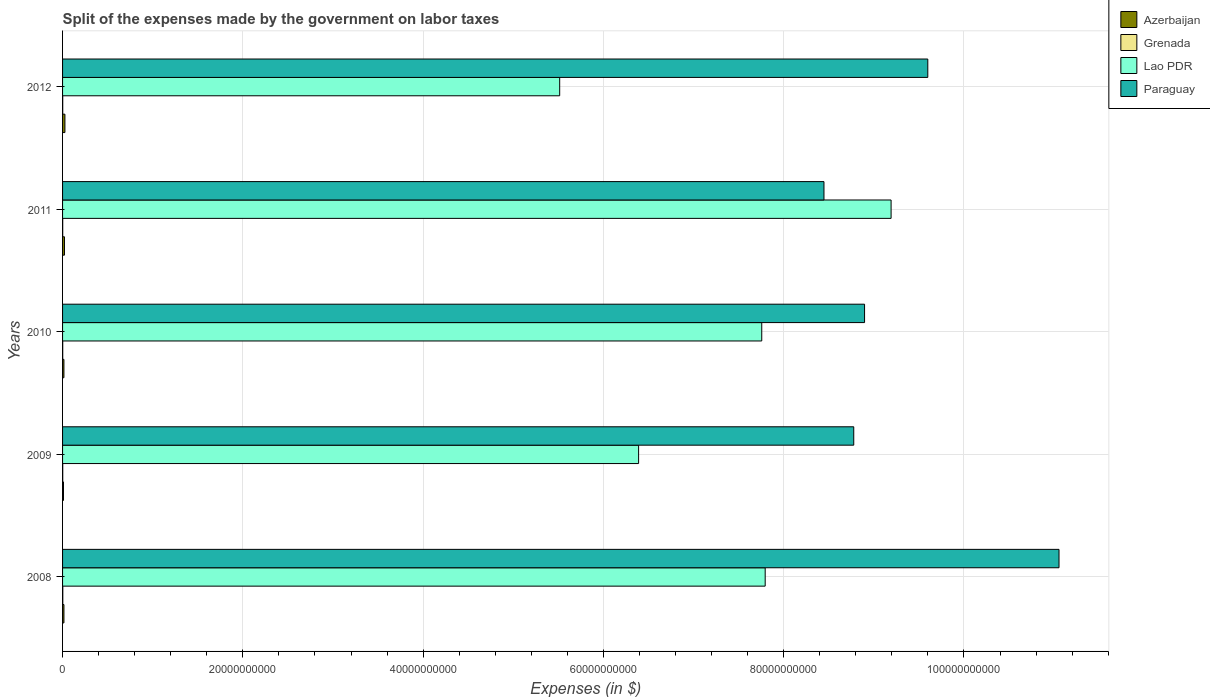How many different coloured bars are there?
Your response must be concise. 4. Are the number of bars per tick equal to the number of legend labels?
Keep it short and to the point. Yes. In how many cases, is the number of bars for a given year not equal to the number of legend labels?
Your answer should be compact. 0. What is the expenses made by the government on labor taxes in Grenada in 2012?
Your answer should be very brief. 1.64e+07. Across all years, what is the maximum expenses made by the government on labor taxes in Azerbaijan?
Your answer should be compact. 2.61e+08. Across all years, what is the minimum expenses made by the government on labor taxes in Paraguay?
Provide a short and direct response. 8.45e+1. What is the total expenses made by the government on labor taxes in Lao PDR in the graph?
Keep it short and to the point. 3.66e+11. What is the difference between the expenses made by the government on labor taxes in Grenada in 2009 and that in 2010?
Make the answer very short. 1.40e+06. What is the difference between the expenses made by the government on labor taxes in Grenada in 2009 and the expenses made by the government on labor taxes in Lao PDR in 2012?
Your answer should be very brief. -5.51e+1. What is the average expenses made by the government on labor taxes in Azerbaijan per year?
Offer a very short reply. 1.75e+08. In the year 2010, what is the difference between the expenses made by the government on labor taxes in Lao PDR and expenses made by the government on labor taxes in Grenada?
Offer a very short reply. 7.76e+1. In how many years, is the expenses made by the government on labor taxes in Lao PDR greater than 36000000000 $?
Your answer should be compact. 5. What is the ratio of the expenses made by the government on labor taxes in Azerbaijan in 2009 to that in 2011?
Make the answer very short. 0.48. Is the expenses made by the government on labor taxes in Grenada in 2009 less than that in 2012?
Ensure brevity in your answer.  No. Is the difference between the expenses made by the government on labor taxes in Lao PDR in 2008 and 2011 greater than the difference between the expenses made by the government on labor taxes in Grenada in 2008 and 2011?
Your response must be concise. No. What is the difference between the highest and the second highest expenses made by the government on labor taxes in Grenada?
Offer a very short reply. 7.20e+06. What is the difference between the highest and the lowest expenses made by the government on labor taxes in Grenada?
Ensure brevity in your answer.  1.11e+07. Is it the case that in every year, the sum of the expenses made by the government on labor taxes in Paraguay and expenses made by the government on labor taxes in Grenada is greater than the sum of expenses made by the government on labor taxes in Azerbaijan and expenses made by the government on labor taxes in Lao PDR?
Keep it short and to the point. Yes. What does the 4th bar from the top in 2009 represents?
Your response must be concise. Azerbaijan. What does the 2nd bar from the bottom in 2012 represents?
Ensure brevity in your answer.  Grenada. Are all the bars in the graph horizontal?
Offer a very short reply. Yes. How many years are there in the graph?
Your answer should be very brief. 5. How many legend labels are there?
Your answer should be very brief. 4. How are the legend labels stacked?
Keep it short and to the point. Vertical. What is the title of the graph?
Keep it short and to the point. Split of the expenses made by the government on labor taxes. What is the label or title of the X-axis?
Keep it short and to the point. Expenses (in $). What is the label or title of the Y-axis?
Provide a succinct answer. Years. What is the Expenses (in $) in Azerbaijan in 2008?
Your answer should be compact. 1.52e+08. What is the Expenses (in $) of Grenada in 2008?
Your response must be concise. 2.60e+07. What is the Expenses (in $) of Lao PDR in 2008?
Offer a very short reply. 7.80e+1. What is the Expenses (in $) of Paraguay in 2008?
Provide a short and direct response. 1.11e+11. What is the Expenses (in $) in Azerbaijan in 2009?
Give a very brief answer. 1.02e+08. What is the Expenses (in $) of Grenada in 2009?
Keep it short and to the point. 1.88e+07. What is the Expenses (in $) of Lao PDR in 2009?
Your answer should be compact. 6.39e+1. What is the Expenses (in $) of Paraguay in 2009?
Offer a very short reply. 8.78e+1. What is the Expenses (in $) of Azerbaijan in 2010?
Your answer should be very brief. 1.51e+08. What is the Expenses (in $) of Grenada in 2010?
Provide a short and direct response. 1.74e+07. What is the Expenses (in $) of Lao PDR in 2010?
Your answer should be compact. 7.76e+1. What is the Expenses (in $) of Paraguay in 2010?
Provide a succinct answer. 8.90e+1. What is the Expenses (in $) of Azerbaijan in 2011?
Your answer should be compact. 2.11e+08. What is the Expenses (in $) of Grenada in 2011?
Your answer should be compact. 1.49e+07. What is the Expenses (in $) in Lao PDR in 2011?
Keep it short and to the point. 9.19e+1. What is the Expenses (in $) in Paraguay in 2011?
Offer a terse response. 8.45e+1. What is the Expenses (in $) of Azerbaijan in 2012?
Offer a terse response. 2.61e+08. What is the Expenses (in $) in Grenada in 2012?
Give a very brief answer. 1.64e+07. What is the Expenses (in $) in Lao PDR in 2012?
Ensure brevity in your answer.  5.52e+1. What is the Expenses (in $) of Paraguay in 2012?
Ensure brevity in your answer.  9.60e+1. Across all years, what is the maximum Expenses (in $) of Azerbaijan?
Keep it short and to the point. 2.61e+08. Across all years, what is the maximum Expenses (in $) of Grenada?
Your response must be concise. 2.60e+07. Across all years, what is the maximum Expenses (in $) of Lao PDR?
Make the answer very short. 9.19e+1. Across all years, what is the maximum Expenses (in $) in Paraguay?
Your response must be concise. 1.11e+11. Across all years, what is the minimum Expenses (in $) in Azerbaijan?
Your answer should be very brief. 1.02e+08. Across all years, what is the minimum Expenses (in $) of Grenada?
Offer a very short reply. 1.49e+07. Across all years, what is the minimum Expenses (in $) of Lao PDR?
Your answer should be compact. 5.52e+1. Across all years, what is the minimum Expenses (in $) in Paraguay?
Your answer should be very brief. 8.45e+1. What is the total Expenses (in $) in Azerbaijan in the graph?
Your response must be concise. 8.77e+08. What is the total Expenses (in $) in Grenada in the graph?
Provide a short and direct response. 9.35e+07. What is the total Expenses (in $) in Lao PDR in the graph?
Your answer should be compact. 3.66e+11. What is the total Expenses (in $) in Paraguay in the graph?
Provide a short and direct response. 4.68e+11. What is the difference between the Expenses (in $) of Azerbaijan in 2008 and that in 2009?
Your answer should be compact. 5.05e+07. What is the difference between the Expenses (in $) of Grenada in 2008 and that in 2009?
Offer a very short reply. 7.20e+06. What is the difference between the Expenses (in $) in Lao PDR in 2008 and that in 2009?
Your answer should be compact. 1.40e+1. What is the difference between the Expenses (in $) of Paraguay in 2008 and that in 2009?
Make the answer very short. 2.28e+1. What is the difference between the Expenses (in $) of Azerbaijan in 2008 and that in 2010?
Provide a short and direct response. 1.30e+06. What is the difference between the Expenses (in $) of Grenada in 2008 and that in 2010?
Ensure brevity in your answer.  8.60e+06. What is the difference between the Expenses (in $) in Lao PDR in 2008 and that in 2010?
Your response must be concise. 3.81e+08. What is the difference between the Expenses (in $) in Paraguay in 2008 and that in 2010?
Offer a very short reply. 2.16e+1. What is the difference between the Expenses (in $) in Azerbaijan in 2008 and that in 2011?
Provide a succinct answer. -5.88e+07. What is the difference between the Expenses (in $) in Grenada in 2008 and that in 2011?
Make the answer very short. 1.11e+07. What is the difference between the Expenses (in $) of Lao PDR in 2008 and that in 2011?
Your response must be concise. -1.40e+1. What is the difference between the Expenses (in $) in Paraguay in 2008 and that in 2011?
Give a very brief answer. 2.61e+1. What is the difference between the Expenses (in $) in Azerbaijan in 2008 and that in 2012?
Your response must be concise. -1.09e+08. What is the difference between the Expenses (in $) in Grenada in 2008 and that in 2012?
Offer a very short reply. 9.60e+06. What is the difference between the Expenses (in $) of Lao PDR in 2008 and that in 2012?
Provide a short and direct response. 2.28e+1. What is the difference between the Expenses (in $) of Paraguay in 2008 and that in 2012?
Your answer should be very brief. 1.46e+1. What is the difference between the Expenses (in $) in Azerbaijan in 2009 and that in 2010?
Offer a very short reply. -4.92e+07. What is the difference between the Expenses (in $) of Grenada in 2009 and that in 2010?
Make the answer very short. 1.40e+06. What is the difference between the Expenses (in $) in Lao PDR in 2009 and that in 2010?
Keep it short and to the point. -1.37e+1. What is the difference between the Expenses (in $) in Paraguay in 2009 and that in 2010?
Your answer should be compact. -1.20e+09. What is the difference between the Expenses (in $) in Azerbaijan in 2009 and that in 2011?
Offer a very short reply. -1.09e+08. What is the difference between the Expenses (in $) of Grenada in 2009 and that in 2011?
Provide a succinct answer. 3.90e+06. What is the difference between the Expenses (in $) in Lao PDR in 2009 and that in 2011?
Provide a succinct answer. -2.80e+1. What is the difference between the Expenses (in $) of Paraguay in 2009 and that in 2011?
Make the answer very short. 3.30e+09. What is the difference between the Expenses (in $) of Azerbaijan in 2009 and that in 2012?
Provide a short and direct response. -1.60e+08. What is the difference between the Expenses (in $) of Grenada in 2009 and that in 2012?
Give a very brief answer. 2.40e+06. What is the difference between the Expenses (in $) of Lao PDR in 2009 and that in 2012?
Ensure brevity in your answer.  8.76e+09. What is the difference between the Expenses (in $) in Paraguay in 2009 and that in 2012?
Your answer should be compact. -8.21e+09. What is the difference between the Expenses (in $) of Azerbaijan in 2010 and that in 2011?
Ensure brevity in your answer.  -6.01e+07. What is the difference between the Expenses (in $) of Grenada in 2010 and that in 2011?
Your response must be concise. 2.50e+06. What is the difference between the Expenses (in $) of Lao PDR in 2010 and that in 2011?
Your response must be concise. -1.43e+1. What is the difference between the Expenses (in $) in Paraguay in 2010 and that in 2011?
Keep it short and to the point. 4.50e+09. What is the difference between the Expenses (in $) of Azerbaijan in 2010 and that in 2012?
Your response must be concise. -1.10e+08. What is the difference between the Expenses (in $) in Lao PDR in 2010 and that in 2012?
Your answer should be compact. 2.24e+1. What is the difference between the Expenses (in $) in Paraguay in 2010 and that in 2012?
Offer a terse response. -7.01e+09. What is the difference between the Expenses (in $) in Azerbaijan in 2011 and that in 2012?
Make the answer very short. -5.04e+07. What is the difference between the Expenses (in $) in Grenada in 2011 and that in 2012?
Provide a short and direct response. -1.50e+06. What is the difference between the Expenses (in $) of Lao PDR in 2011 and that in 2012?
Ensure brevity in your answer.  3.68e+1. What is the difference between the Expenses (in $) of Paraguay in 2011 and that in 2012?
Keep it short and to the point. -1.15e+1. What is the difference between the Expenses (in $) in Azerbaijan in 2008 and the Expenses (in $) in Grenada in 2009?
Offer a terse response. 1.33e+08. What is the difference between the Expenses (in $) of Azerbaijan in 2008 and the Expenses (in $) of Lao PDR in 2009?
Offer a terse response. -6.38e+1. What is the difference between the Expenses (in $) of Azerbaijan in 2008 and the Expenses (in $) of Paraguay in 2009?
Give a very brief answer. -8.76e+1. What is the difference between the Expenses (in $) in Grenada in 2008 and the Expenses (in $) in Lao PDR in 2009?
Keep it short and to the point. -6.39e+1. What is the difference between the Expenses (in $) in Grenada in 2008 and the Expenses (in $) in Paraguay in 2009?
Offer a terse response. -8.77e+1. What is the difference between the Expenses (in $) in Lao PDR in 2008 and the Expenses (in $) in Paraguay in 2009?
Offer a very short reply. -9.82e+09. What is the difference between the Expenses (in $) of Azerbaijan in 2008 and the Expenses (in $) of Grenada in 2010?
Give a very brief answer. 1.35e+08. What is the difference between the Expenses (in $) of Azerbaijan in 2008 and the Expenses (in $) of Lao PDR in 2010?
Ensure brevity in your answer.  -7.74e+1. What is the difference between the Expenses (in $) of Azerbaijan in 2008 and the Expenses (in $) of Paraguay in 2010?
Your answer should be very brief. -8.88e+1. What is the difference between the Expenses (in $) of Grenada in 2008 and the Expenses (in $) of Lao PDR in 2010?
Ensure brevity in your answer.  -7.75e+1. What is the difference between the Expenses (in $) in Grenada in 2008 and the Expenses (in $) in Paraguay in 2010?
Offer a terse response. -8.89e+1. What is the difference between the Expenses (in $) of Lao PDR in 2008 and the Expenses (in $) of Paraguay in 2010?
Offer a terse response. -1.10e+1. What is the difference between the Expenses (in $) of Azerbaijan in 2008 and the Expenses (in $) of Grenada in 2011?
Give a very brief answer. 1.37e+08. What is the difference between the Expenses (in $) of Azerbaijan in 2008 and the Expenses (in $) of Lao PDR in 2011?
Your answer should be compact. -9.18e+1. What is the difference between the Expenses (in $) of Azerbaijan in 2008 and the Expenses (in $) of Paraguay in 2011?
Offer a terse response. -8.43e+1. What is the difference between the Expenses (in $) of Grenada in 2008 and the Expenses (in $) of Lao PDR in 2011?
Your answer should be compact. -9.19e+1. What is the difference between the Expenses (in $) in Grenada in 2008 and the Expenses (in $) in Paraguay in 2011?
Make the answer very short. -8.44e+1. What is the difference between the Expenses (in $) in Lao PDR in 2008 and the Expenses (in $) in Paraguay in 2011?
Keep it short and to the point. -6.52e+09. What is the difference between the Expenses (in $) of Azerbaijan in 2008 and the Expenses (in $) of Grenada in 2012?
Provide a succinct answer. 1.36e+08. What is the difference between the Expenses (in $) of Azerbaijan in 2008 and the Expenses (in $) of Lao PDR in 2012?
Provide a short and direct response. -5.50e+1. What is the difference between the Expenses (in $) of Azerbaijan in 2008 and the Expenses (in $) of Paraguay in 2012?
Offer a terse response. -9.58e+1. What is the difference between the Expenses (in $) in Grenada in 2008 and the Expenses (in $) in Lao PDR in 2012?
Provide a succinct answer. -5.51e+1. What is the difference between the Expenses (in $) in Grenada in 2008 and the Expenses (in $) in Paraguay in 2012?
Give a very brief answer. -9.60e+1. What is the difference between the Expenses (in $) of Lao PDR in 2008 and the Expenses (in $) of Paraguay in 2012?
Your answer should be compact. -1.80e+1. What is the difference between the Expenses (in $) in Azerbaijan in 2009 and the Expenses (in $) in Grenada in 2010?
Provide a succinct answer. 8.43e+07. What is the difference between the Expenses (in $) in Azerbaijan in 2009 and the Expenses (in $) in Lao PDR in 2010?
Provide a short and direct response. -7.75e+1. What is the difference between the Expenses (in $) of Azerbaijan in 2009 and the Expenses (in $) of Paraguay in 2010?
Keep it short and to the point. -8.89e+1. What is the difference between the Expenses (in $) in Grenada in 2009 and the Expenses (in $) in Lao PDR in 2010?
Your response must be concise. -7.76e+1. What is the difference between the Expenses (in $) of Grenada in 2009 and the Expenses (in $) of Paraguay in 2010?
Your answer should be compact. -8.90e+1. What is the difference between the Expenses (in $) in Lao PDR in 2009 and the Expenses (in $) in Paraguay in 2010?
Your response must be concise. -2.51e+1. What is the difference between the Expenses (in $) in Azerbaijan in 2009 and the Expenses (in $) in Grenada in 2011?
Provide a short and direct response. 8.68e+07. What is the difference between the Expenses (in $) in Azerbaijan in 2009 and the Expenses (in $) in Lao PDR in 2011?
Give a very brief answer. -9.18e+1. What is the difference between the Expenses (in $) of Azerbaijan in 2009 and the Expenses (in $) of Paraguay in 2011?
Offer a terse response. -8.44e+1. What is the difference between the Expenses (in $) in Grenada in 2009 and the Expenses (in $) in Lao PDR in 2011?
Ensure brevity in your answer.  -9.19e+1. What is the difference between the Expenses (in $) in Grenada in 2009 and the Expenses (in $) in Paraguay in 2011?
Your response must be concise. -8.45e+1. What is the difference between the Expenses (in $) of Lao PDR in 2009 and the Expenses (in $) of Paraguay in 2011?
Your answer should be compact. -2.06e+1. What is the difference between the Expenses (in $) in Azerbaijan in 2009 and the Expenses (in $) in Grenada in 2012?
Offer a terse response. 8.53e+07. What is the difference between the Expenses (in $) of Azerbaijan in 2009 and the Expenses (in $) of Lao PDR in 2012?
Offer a very short reply. -5.50e+1. What is the difference between the Expenses (in $) of Azerbaijan in 2009 and the Expenses (in $) of Paraguay in 2012?
Your answer should be compact. -9.59e+1. What is the difference between the Expenses (in $) of Grenada in 2009 and the Expenses (in $) of Lao PDR in 2012?
Ensure brevity in your answer.  -5.51e+1. What is the difference between the Expenses (in $) in Grenada in 2009 and the Expenses (in $) in Paraguay in 2012?
Your response must be concise. -9.60e+1. What is the difference between the Expenses (in $) in Lao PDR in 2009 and the Expenses (in $) in Paraguay in 2012?
Your response must be concise. -3.21e+1. What is the difference between the Expenses (in $) of Azerbaijan in 2010 and the Expenses (in $) of Grenada in 2011?
Provide a short and direct response. 1.36e+08. What is the difference between the Expenses (in $) in Azerbaijan in 2010 and the Expenses (in $) in Lao PDR in 2011?
Your answer should be very brief. -9.18e+1. What is the difference between the Expenses (in $) in Azerbaijan in 2010 and the Expenses (in $) in Paraguay in 2011?
Make the answer very short. -8.43e+1. What is the difference between the Expenses (in $) of Grenada in 2010 and the Expenses (in $) of Lao PDR in 2011?
Offer a terse response. -9.19e+1. What is the difference between the Expenses (in $) of Grenada in 2010 and the Expenses (in $) of Paraguay in 2011?
Offer a very short reply. -8.45e+1. What is the difference between the Expenses (in $) in Lao PDR in 2010 and the Expenses (in $) in Paraguay in 2011?
Provide a succinct answer. -6.90e+09. What is the difference between the Expenses (in $) of Azerbaijan in 2010 and the Expenses (in $) of Grenada in 2012?
Ensure brevity in your answer.  1.34e+08. What is the difference between the Expenses (in $) of Azerbaijan in 2010 and the Expenses (in $) of Lao PDR in 2012?
Your answer should be very brief. -5.50e+1. What is the difference between the Expenses (in $) in Azerbaijan in 2010 and the Expenses (in $) in Paraguay in 2012?
Give a very brief answer. -9.58e+1. What is the difference between the Expenses (in $) of Grenada in 2010 and the Expenses (in $) of Lao PDR in 2012?
Make the answer very short. -5.51e+1. What is the difference between the Expenses (in $) in Grenada in 2010 and the Expenses (in $) in Paraguay in 2012?
Keep it short and to the point. -9.60e+1. What is the difference between the Expenses (in $) of Lao PDR in 2010 and the Expenses (in $) of Paraguay in 2012?
Give a very brief answer. -1.84e+1. What is the difference between the Expenses (in $) in Azerbaijan in 2011 and the Expenses (in $) in Grenada in 2012?
Offer a very short reply. 1.95e+08. What is the difference between the Expenses (in $) of Azerbaijan in 2011 and the Expenses (in $) of Lao PDR in 2012?
Make the answer very short. -5.49e+1. What is the difference between the Expenses (in $) of Azerbaijan in 2011 and the Expenses (in $) of Paraguay in 2012?
Give a very brief answer. -9.58e+1. What is the difference between the Expenses (in $) in Grenada in 2011 and the Expenses (in $) in Lao PDR in 2012?
Offer a terse response. -5.51e+1. What is the difference between the Expenses (in $) of Grenada in 2011 and the Expenses (in $) of Paraguay in 2012?
Make the answer very short. -9.60e+1. What is the difference between the Expenses (in $) in Lao PDR in 2011 and the Expenses (in $) in Paraguay in 2012?
Make the answer very short. -4.07e+09. What is the average Expenses (in $) of Azerbaijan per year?
Keep it short and to the point. 1.75e+08. What is the average Expenses (in $) in Grenada per year?
Your answer should be very brief. 1.87e+07. What is the average Expenses (in $) of Lao PDR per year?
Provide a succinct answer. 7.33e+1. What is the average Expenses (in $) in Paraguay per year?
Provide a succinct answer. 9.36e+1. In the year 2008, what is the difference between the Expenses (in $) of Azerbaijan and Expenses (in $) of Grenada?
Make the answer very short. 1.26e+08. In the year 2008, what is the difference between the Expenses (in $) in Azerbaijan and Expenses (in $) in Lao PDR?
Your answer should be very brief. -7.78e+1. In the year 2008, what is the difference between the Expenses (in $) in Azerbaijan and Expenses (in $) in Paraguay?
Your response must be concise. -1.10e+11. In the year 2008, what is the difference between the Expenses (in $) of Grenada and Expenses (in $) of Lao PDR?
Keep it short and to the point. -7.79e+1. In the year 2008, what is the difference between the Expenses (in $) in Grenada and Expenses (in $) in Paraguay?
Give a very brief answer. -1.11e+11. In the year 2008, what is the difference between the Expenses (in $) in Lao PDR and Expenses (in $) in Paraguay?
Offer a very short reply. -3.26e+1. In the year 2009, what is the difference between the Expenses (in $) in Azerbaijan and Expenses (in $) in Grenada?
Provide a short and direct response. 8.29e+07. In the year 2009, what is the difference between the Expenses (in $) in Azerbaijan and Expenses (in $) in Lao PDR?
Offer a very short reply. -6.38e+1. In the year 2009, what is the difference between the Expenses (in $) of Azerbaijan and Expenses (in $) of Paraguay?
Give a very brief answer. -8.77e+1. In the year 2009, what is the difference between the Expenses (in $) of Grenada and Expenses (in $) of Lao PDR?
Make the answer very short. -6.39e+1. In the year 2009, what is the difference between the Expenses (in $) in Grenada and Expenses (in $) in Paraguay?
Make the answer very short. -8.78e+1. In the year 2009, what is the difference between the Expenses (in $) of Lao PDR and Expenses (in $) of Paraguay?
Ensure brevity in your answer.  -2.39e+1. In the year 2010, what is the difference between the Expenses (in $) in Azerbaijan and Expenses (in $) in Grenada?
Offer a terse response. 1.34e+08. In the year 2010, what is the difference between the Expenses (in $) in Azerbaijan and Expenses (in $) in Lao PDR?
Your response must be concise. -7.74e+1. In the year 2010, what is the difference between the Expenses (in $) in Azerbaijan and Expenses (in $) in Paraguay?
Your answer should be very brief. -8.88e+1. In the year 2010, what is the difference between the Expenses (in $) of Grenada and Expenses (in $) of Lao PDR?
Ensure brevity in your answer.  -7.76e+1. In the year 2010, what is the difference between the Expenses (in $) of Grenada and Expenses (in $) of Paraguay?
Give a very brief answer. -8.90e+1. In the year 2010, what is the difference between the Expenses (in $) of Lao PDR and Expenses (in $) of Paraguay?
Your answer should be compact. -1.14e+1. In the year 2011, what is the difference between the Expenses (in $) of Azerbaijan and Expenses (in $) of Grenada?
Your response must be concise. 1.96e+08. In the year 2011, what is the difference between the Expenses (in $) in Azerbaijan and Expenses (in $) in Lao PDR?
Offer a very short reply. -9.17e+1. In the year 2011, what is the difference between the Expenses (in $) of Azerbaijan and Expenses (in $) of Paraguay?
Give a very brief answer. -8.43e+1. In the year 2011, what is the difference between the Expenses (in $) of Grenada and Expenses (in $) of Lao PDR?
Ensure brevity in your answer.  -9.19e+1. In the year 2011, what is the difference between the Expenses (in $) of Grenada and Expenses (in $) of Paraguay?
Your response must be concise. -8.45e+1. In the year 2011, what is the difference between the Expenses (in $) in Lao PDR and Expenses (in $) in Paraguay?
Give a very brief answer. 7.45e+09. In the year 2012, what is the difference between the Expenses (in $) in Azerbaijan and Expenses (in $) in Grenada?
Offer a terse response. 2.45e+08. In the year 2012, what is the difference between the Expenses (in $) in Azerbaijan and Expenses (in $) in Lao PDR?
Make the answer very short. -5.49e+1. In the year 2012, what is the difference between the Expenses (in $) of Azerbaijan and Expenses (in $) of Paraguay?
Keep it short and to the point. -9.57e+1. In the year 2012, what is the difference between the Expenses (in $) of Grenada and Expenses (in $) of Lao PDR?
Offer a very short reply. -5.51e+1. In the year 2012, what is the difference between the Expenses (in $) of Grenada and Expenses (in $) of Paraguay?
Keep it short and to the point. -9.60e+1. In the year 2012, what is the difference between the Expenses (in $) of Lao PDR and Expenses (in $) of Paraguay?
Your response must be concise. -4.08e+1. What is the ratio of the Expenses (in $) in Azerbaijan in 2008 to that in 2009?
Provide a succinct answer. 1.5. What is the ratio of the Expenses (in $) of Grenada in 2008 to that in 2009?
Provide a succinct answer. 1.38. What is the ratio of the Expenses (in $) of Lao PDR in 2008 to that in 2009?
Provide a succinct answer. 1.22. What is the ratio of the Expenses (in $) of Paraguay in 2008 to that in 2009?
Provide a short and direct response. 1.26. What is the ratio of the Expenses (in $) of Azerbaijan in 2008 to that in 2010?
Give a very brief answer. 1.01. What is the ratio of the Expenses (in $) in Grenada in 2008 to that in 2010?
Offer a terse response. 1.49. What is the ratio of the Expenses (in $) in Paraguay in 2008 to that in 2010?
Your answer should be very brief. 1.24. What is the ratio of the Expenses (in $) of Azerbaijan in 2008 to that in 2011?
Keep it short and to the point. 0.72. What is the ratio of the Expenses (in $) of Grenada in 2008 to that in 2011?
Offer a very short reply. 1.75. What is the ratio of the Expenses (in $) in Lao PDR in 2008 to that in 2011?
Keep it short and to the point. 0.85. What is the ratio of the Expenses (in $) of Paraguay in 2008 to that in 2011?
Your answer should be very brief. 1.31. What is the ratio of the Expenses (in $) in Azerbaijan in 2008 to that in 2012?
Offer a terse response. 0.58. What is the ratio of the Expenses (in $) in Grenada in 2008 to that in 2012?
Provide a succinct answer. 1.59. What is the ratio of the Expenses (in $) in Lao PDR in 2008 to that in 2012?
Give a very brief answer. 1.41. What is the ratio of the Expenses (in $) in Paraguay in 2008 to that in 2012?
Keep it short and to the point. 1.15. What is the ratio of the Expenses (in $) of Azerbaijan in 2009 to that in 2010?
Offer a terse response. 0.67. What is the ratio of the Expenses (in $) in Grenada in 2009 to that in 2010?
Provide a short and direct response. 1.08. What is the ratio of the Expenses (in $) in Lao PDR in 2009 to that in 2010?
Provide a short and direct response. 0.82. What is the ratio of the Expenses (in $) of Paraguay in 2009 to that in 2010?
Offer a terse response. 0.99. What is the ratio of the Expenses (in $) of Azerbaijan in 2009 to that in 2011?
Make the answer very short. 0.48. What is the ratio of the Expenses (in $) in Grenada in 2009 to that in 2011?
Your response must be concise. 1.26. What is the ratio of the Expenses (in $) in Lao PDR in 2009 to that in 2011?
Offer a terse response. 0.7. What is the ratio of the Expenses (in $) of Paraguay in 2009 to that in 2011?
Offer a terse response. 1.04. What is the ratio of the Expenses (in $) in Azerbaijan in 2009 to that in 2012?
Your answer should be very brief. 0.39. What is the ratio of the Expenses (in $) of Grenada in 2009 to that in 2012?
Keep it short and to the point. 1.15. What is the ratio of the Expenses (in $) in Lao PDR in 2009 to that in 2012?
Your answer should be very brief. 1.16. What is the ratio of the Expenses (in $) in Paraguay in 2009 to that in 2012?
Your answer should be compact. 0.91. What is the ratio of the Expenses (in $) of Azerbaijan in 2010 to that in 2011?
Offer a very short reply. 0.72. What is the ratio of the Expenses (in $) in Grenada in 2010 to that in 2011?
Provide a short and direct response. 1.17. What is the ratio of the Expenses (in $) of Lao PDR in 2010 to that in 2011?
Ensure brevity in your answer.  0.84. What is the ratio of the Expenses (in $) of Paraguay in 2010 to that in 2011?
Ensure brevity in your answer.  1.05. What is the ratio of the Expenses (in $) in Azerbaijan in 2010 to that in 2012?
Make the answer very short. 0.58. What is the ratio of the Expenses (in $) in Grenada in 2010 to that in 2012?
Make the answer very short. 1.06. What is the ratio of the Expenses (in $) in Lao PDR in 2010 to that in 2012?
Offer a very short reply. 1.41. What is the ratio of the Expenses (in $) in Paraguay in 2010 to that in 2012?
Ensure brevity in your answer.  0.93. What is the ratio of the Expenses (in $) of Azerbaijan in 2011 to that in 2012?
Keep it short and to the point. 0.81. What is the ratio of the Expenses (in $) in Grenada in 2011 to that in 2012?
Offer a very short reply. 0.91. What is the ratio of the Expenses (in $) of Paraguay in 2011 to that in 2012?
Make the answer very short. 0.88. What is the difference between the highest and the second highest Expenses (in $) in Azerbaijan?
Your response must be concise. 5.04e+07. What is the difference between the highest and the second highest Expenses (in $) of Grenada?
Ensure brevity in your answer.  7.20e+06. What is the difference between the highest and the second highest Expenses (in $) in Lao PDR?
Ensure brevity in your answer.  1.40e+1. What is the difference between the highest and the second highest Expenses (in $) in Paraguay?
Your answer should be compact. 1.46e+1. What is the difference between the highest and the lowest Expenses (in $) of Azerbaijan?
Provide a short and direct response. 1.60e+08. What is the difference between the highest and the lowest Expenses (in $) in Grenada?
Offer a very short reply. 1.11e+07. What is the difference between the highest and the lowest Expenses (in $) of Lao PDR?
Your response must be concise. 3.68e+1. What is the difference between the highest and the lowest Expenses (in $) of Paraguay?
Provide a short and direct response. 2.61e+1. 